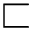Convert formula to latex. <formula><loc_0><loc_0><loc_500><loc_500>\sqsubset</formula> 